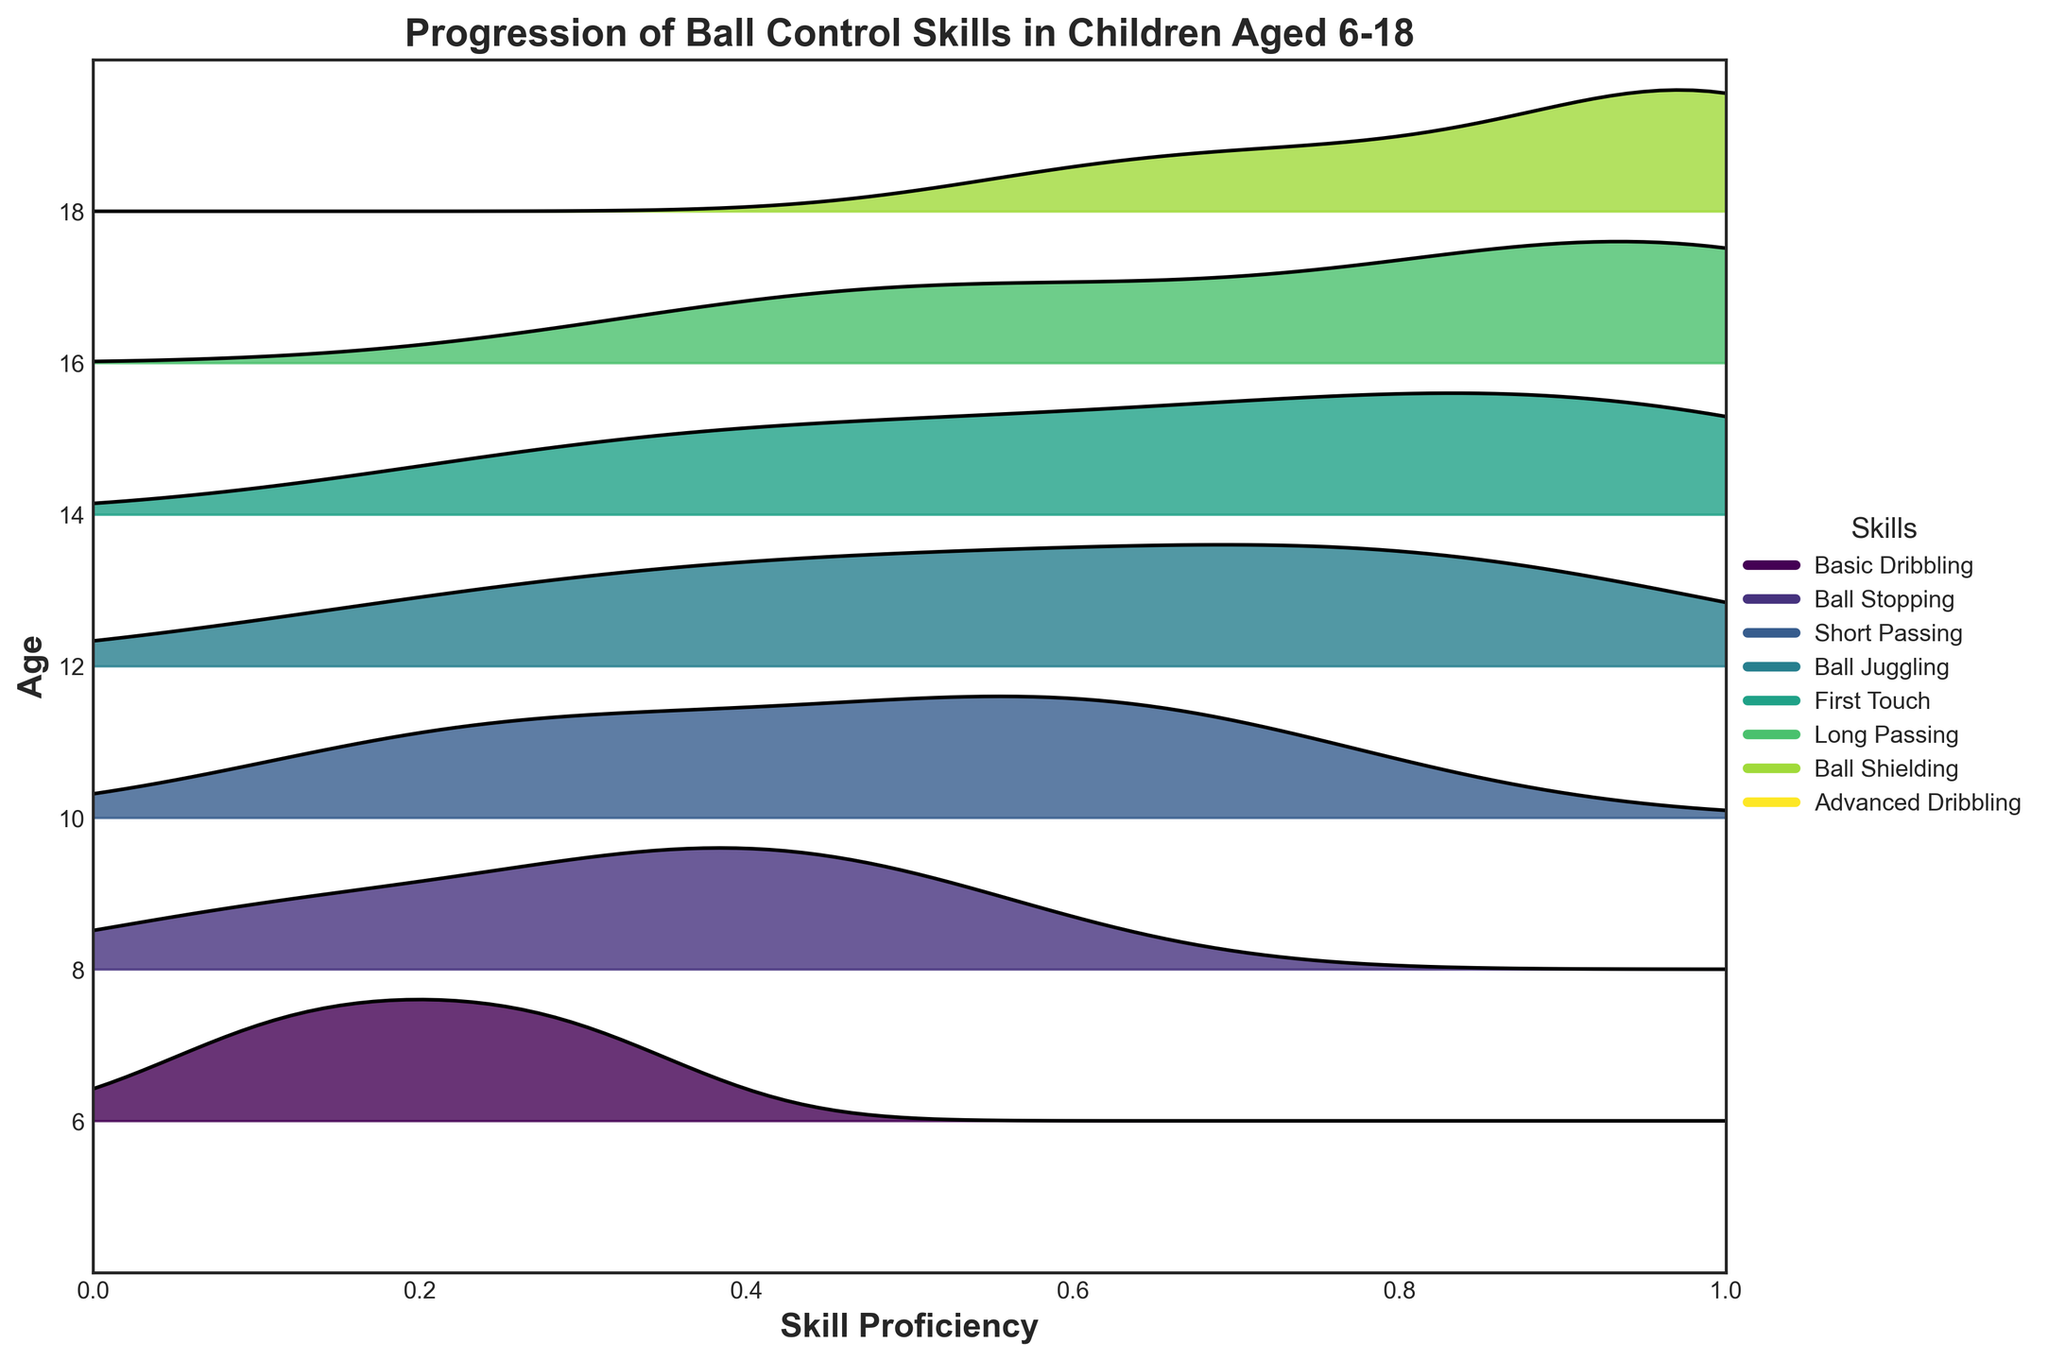What are the axes labeled on the plot? The x-axis is labeled 'Skill Proficiency' and the y-axis is labeled 'Age'.
Answer: Skill Proficiency (x-axis) and Age (y-axis) What is the plot's title? The title of the plot, located at the top center, is 'Progression of Ball Control Skills in Children Aged 6-18'.
Answer: Progression of Ball Control Skills in Children Aged 6-18 How many different ages are represented in the plot? The plot represents 7 different ages, which are visible on the y-axis. Specifically, the ages are 6, 8, 10, 12, 14, 16, and 18.
Answer: 7 Which skill has the highest proficiency for children aged 10? By looking at the section for age 10, 'Ball Stopping' has the highest peak compared to other skills for that age group.
Answer: Ball Stopping How does the skill 'Ball Stopping' change as children age from 6 to 18? 'Ball Stopping' shows a clear progression, starting from a proficiency value of 0.3 at age 6, steadily increasing, and reaching the maximum value of 1.0 by age 14, then maintaining at 1.0 through age 18.
Answer: Increases to 1.0 by age 14 What two skills have equal proficiency for children aged 16? For age 16, both 'Basic Dribbling' and 'Short Passing' reach the maximum possible proficiency value of 1.0.
Answer: Basic Dribbling and Short Passing Which skill shows the largest increase in proficiency between ages 8 and 12? Between ages 8 and 12, 'Ball Juggling' shows the largest increase in proficiency, from 0.1 to 0.5 respectively, a difference of 0.4.
Answer: Ball Juggling Compare the skills 'Long Passing' and 'Advanced Dribbling' for children aged 18. Which one is more proficient? At age 18, 'Long Passing' has a proficiency of 0.8, whereas 'Advanced Dribbling' has a proficiency of 0.6, making 'Long Passing' more proficient.
Answer: Long Passing At what age do children start learning 'Advanced Dribbling'? Children start learning 'Advanced Dribbling' at age 16, as this skill first appears in the plot at that age.
Answer: 16 